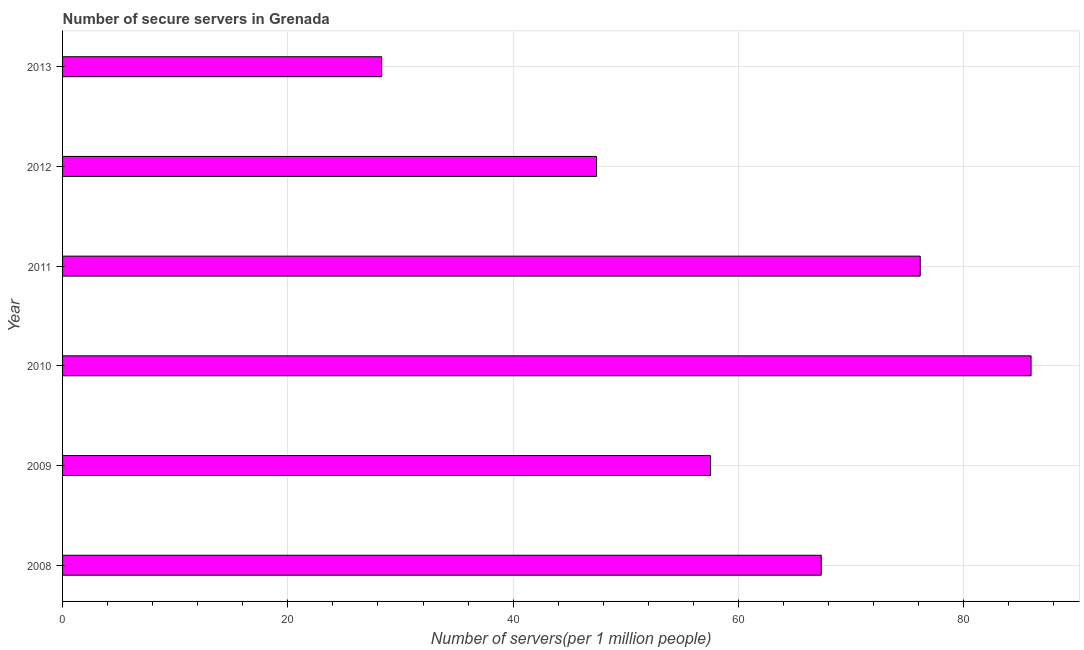What is the title of the graph?
Provide a short and direct response. Number of secure servers in Grenada. What is the label or title of the X-axis?
Offer a terse response. Number of servers(per 1 million people). What is the label or title of the Y-axis?
Give a very brief answer. Year. What is the number of secure internet servers in 2008?
Your answer should be compact. 67.35. Across all years, what is the maximum number of secure internet servers?
Offer a very short reply. 85.98. Across all years, what is the minimum number of secure internet servers?
Your answer should be very brief. 28.33. In which year was the number of secure internet servers minimum?
Offer a terse response. 2013. What is the sum of the number of secure internet servers?
Offer a very short reply. 362.73. What is the difference between the number of secure internet servers in 2008 and 2009?
Make the answer very short. 9.82. What is the average number of secure internet servers per year?
Provide a succinct answer. 60.45. What is the median number of secure internet servers?
Provide a succinct answer. 62.44. Do a majority of the years between 2013 and 2012 (inclusive) have number of secure internet servers greater than 16 ?
Offer a terse response. No. What is the ratio of the number of secure internet servers in 2009 to that in 2012?
Keep it short and to the point. 1.21. Is the number of secure internet servers in 2008 less than that in 2011?
Offer a very short reply. Yes. What is the difference between the highest and the second highest number of secure internet servers?
Offer a terse response. 9.84. What is the difference between the highest and the lowest number of secure internet servers?
Your answer should be compact. 57.65. Are all the bars in the graph horizontal?
Keep it short and to the point. Yes. How many years are there in the graph?
Make the answer very short. 6. What is the Number of servers(per 1 million people) in 2008?
Your answer should be very brief. 67.35. What is the Number of servers(per 1 million people) of 2009?
Your answer should be compact. 57.53. What is the Number of servers(per 1 million people) in 2010?
Provide a succinct answer. 85.98. What is the Number of servers(per 1 million people) of 2011?
Give a very brief answer. 76.14. What is the Number of servers(per 1 million people) of 2012?
Ensure brevity in your answer.  47.4. What is the Number of servers(per 1 million people) in 2013?
Your response must be concise. 28.33. What is the difference between the Number of servers(per 1 million people) in 2008 and 2009?
Make the answer very short. 9.82. What is the difference between the Number of servers(per 1 million people) in 2008 and 2010?
Your response must be concise. -18.63. What is the difference between the Number of servers(per 1 million people) in 2008 and 2011?
Keep it short and to the point. -8.79. What is the difference between the Number of servers(per 1 million people) in 2008 and 2012?
Provide a succinct answer. 19.95. What is the difference between the Number of servers(per 1 million people) in 2008 and 2013?
Provide a succinct answer. 39.02. What is the difference between the Number of servers(per 1 million people) in 2009 and 2010?
Offer a very short reply. -28.45. What is the difference between the Number of servers(per 1 million people) in 2009 and 2011?
Keep it short and to the point. -18.61. What is the difference between the Number of servers(per 1 million people) in 2009 and 2012?
Keep it short and to the point. 10.12. What is the difference between the Number of servers(per 1 million people) in 2009 and 2013?
Your response must be concise. 29.2. What is the difference between the Number of servers(per 1 million people) in 2010 and 2011?
Ensure brevity in your answer.  9.84. What is the difference between the Number of servers(per 1 million people) in 2010 and 2012?
Keep it short and to the point. 38.57. What is the difference between the Number of servers(per 1 million people) in 2010 and 2013?
Your response must be concise. 57.65. What is the difference between the Number of servers(per 1 million people) in 2011 and 2012?
Your answer should be very brief. 28.74. What is the difference between the Number of servers(per 1 million people) in 2011 and 2013?
Make the answer very short. 47.81. What is the difference between the Number of servers(per 1 million people) in 2012 and 2013?
Offer a terse response. 19.08. What is the ratio of the Number of servers(per 1 million people) in 2008 to that in 2009?
Your answer should be compact. 1.17. What is the ratio of the Number of servers(per 1 million people) in 2008 to that in 2010?
Your response must be concise. 0.78. What is the ratio of the Number of servers(per 1 million people) in 2008 to that in 2011?
Your answer should be compact. 0.89. What is the ratio of the Number of servers(per 1 million people) in 2008 to that in 2012?
Make the answer very short. 1.42. What is the ratio of the Number of servers(per 1 million people) in 2008 to that in 2013?
Your answer should be very brief. 2.38. What is the ratio of the Number of servers(per 1 million people) in 2009 to that in 2010?
Offer a very short reply. 0.67. What is the ratio of the Number of servers(per 1 million people) in 2009 to that in 2011?
Make the answer very short. 0.76. What is the ratio of the Number of servers(per 1 million people) in 2009 to that in 2012?
Make the answer very short. 1.21. What is the ratio of the Number of servers(per 1 million people) in 2009 to that in 2013?
Your answer should be compact. 2.03. What is the ratio of the Number of servers(per 1 million people) in 2010 to that in 2011?
Make the answer very short. 1.13. What is the ratio of the Number of servers(per 1 million people) in 2010 to that in 2012?
Provide a short and direct response. 1.81. What is the ratio of the Number of servers(per 1 million people) in 2010 to that in 2013?
Offer a very short reply. 3.04. What is the ratio of the Number of servers(per 1 million people) in 2011 to that in 2012?
Provide a short and direct response. 1.61. What is the ratio of the Number of servers(per 1 million people) in 2011 to that in 2013?
Give a very brief answer. 2.69. What is the ratio of the Number of servers(per 1 million people) in 2012 to that in 2013?
Keep it short and to the point. 1.67. 